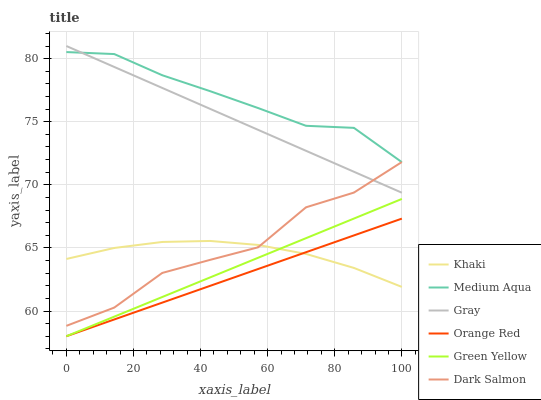Does Orange Red have the minimum area under the curve?
Answer yes or no. Yes. Does Medium Aqua have the maximum area under the curve?
Answer yes or no. Yes. Does Khaki have the minimum area under the curve?
Answer yes or no. No. Does Khaki have the maximum area under the curve?
Answer yes or no. No. Is Orange Red the smoothest?
Answer yes or no. Yes. Is Dark Salmon the roughest?
Answer yes or no. Yes. Is Khaki the smoothest?
Answer yes or no. No. Is Khaki the roughest?
Answer yes or no. No. Does Khaki have the lowest value?
Answer yes or no. No. Does Dark Salmon have the highest value?
Answer yes or no. No. Is Orange Red less than Medium Aqua?
Answer yes or no. Yes. Is Medium Aqua greater than Orange Red?
Answer yes or no. Yes. Does Orange Red intersect Medium Aqua?
Answer yes or no. No. 